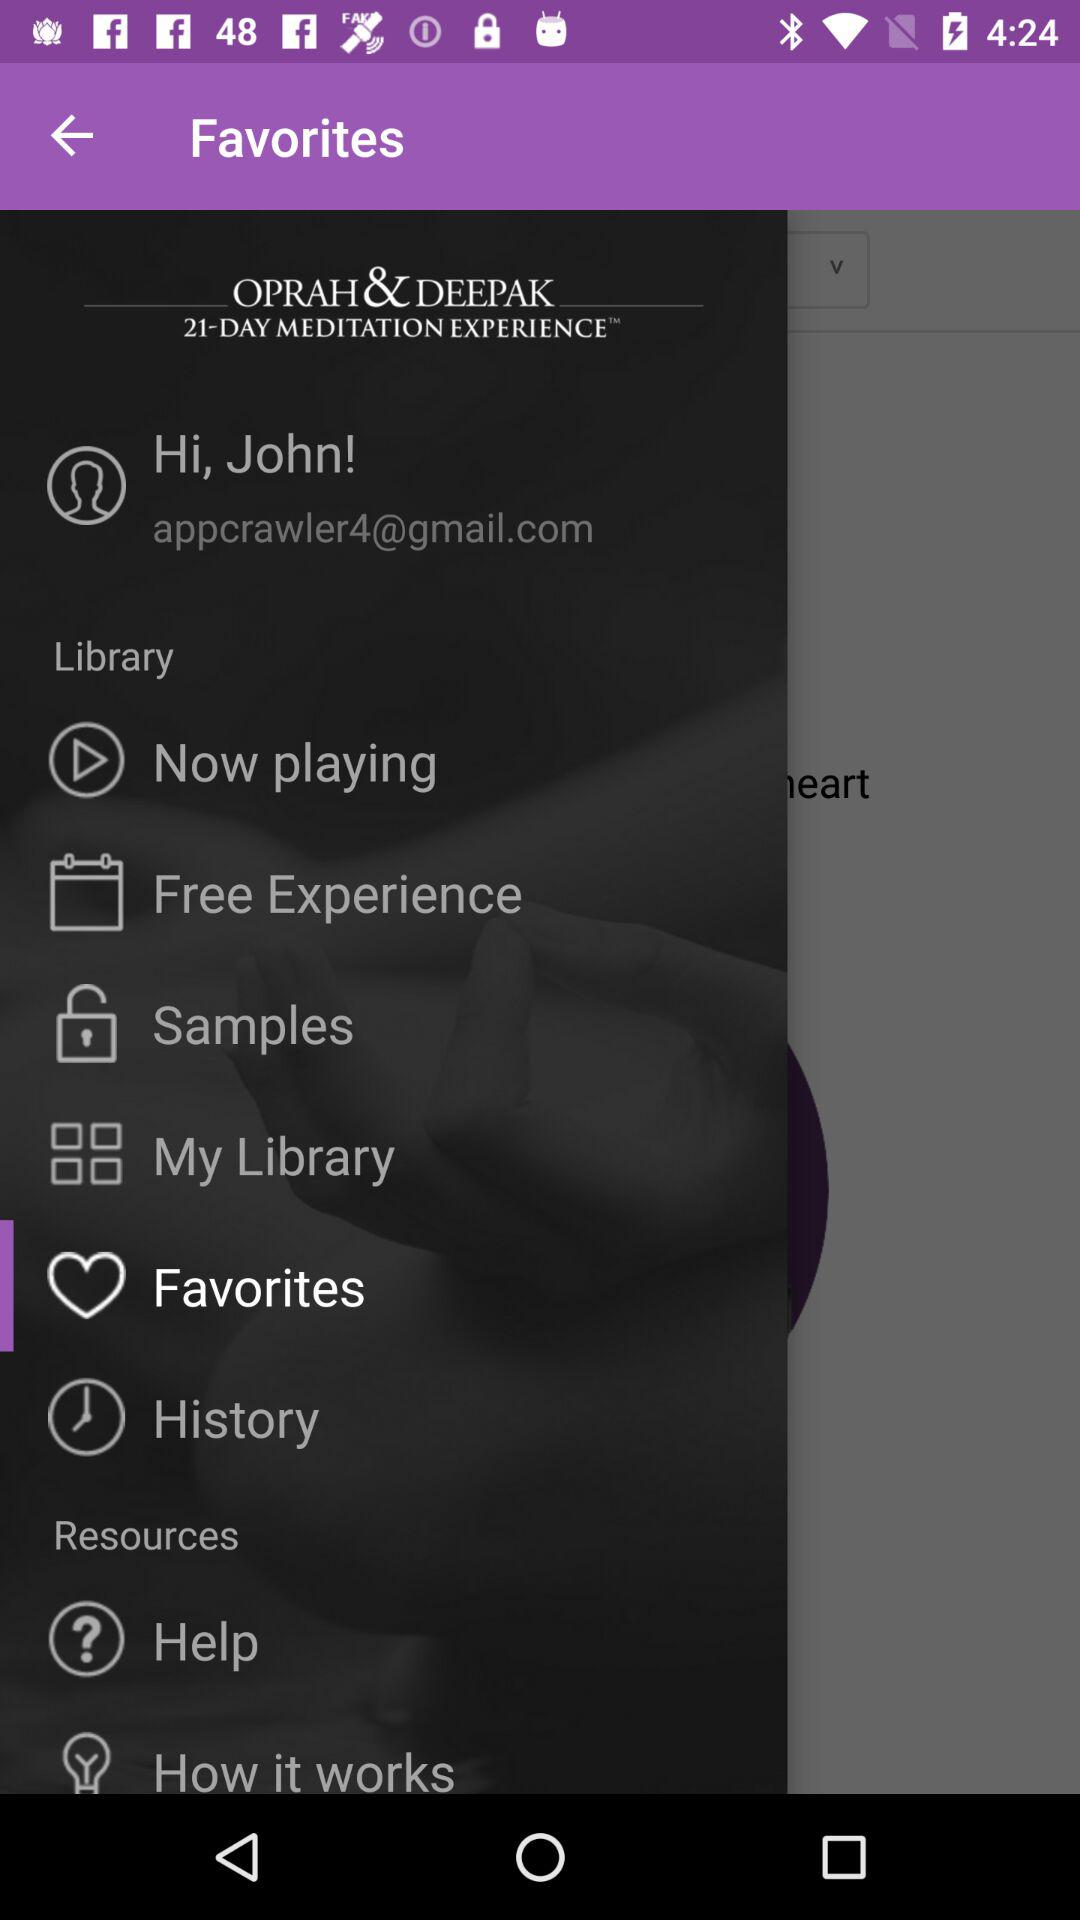How many days of meditation experience are given here? The number of days is 21. 